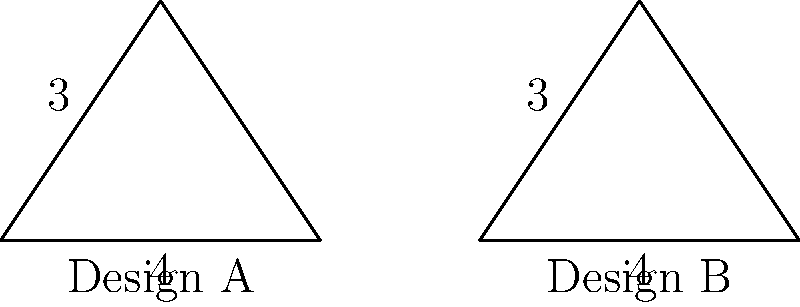Two self-driving taxi designs, A and B, have triangular safety sensor configurations as shown above. Which of the following statements about the congruence of these designs is correct?

a) The triangles are congruent because they have the same base and height.
b) The triangles are not congruent because their orientations are different.
c) The triangles are congruent because they have three pairs of congruent sides.
d) There is not enough information to determine if the triangles are congruent. To determine if the triangles are congruent, we need to analyze the given information:

1. Both triangles have a base of 4 units and a height of 3 units.
2. The triangles appear to be isosceles, with the base as the unequal side.

To prove congruence, we need to establish one of the following:
- SSS (Side-Side-Side)
- SAS (Side-Angle-Side)
- ASA (Angle-Side-Angle)
- AAS (Angle-Angle-Side)

Let's check if we have enough information:

1. We know the base (4 units) and height (3 units) of both triangles.
2. Using the Pythagorean theorem, we can calculate the length of the equal sides:
   $\text{side}^2 = (\frac{4}{2})^2 + 3^2 = 2^2 + 3^2 = 4 + 9 = 13$
   $\text{side} = \sqrt{13}$

3. Now we have all three sides of both triangles:
   - Base: 4 units
   - Two equal sides: $\sqrt{13}$ units each

4. Since all three pairs of corresponding sides are equal, we can conclude that the triangles are congruent by the SSS (Side-Side-Side) congruence criterion.

Therefore, the correct answer is c) The triangles are congruent because they have three pairs of congruent sides.
Answer: c) The triangles are congruent because they have three pairs of congruent sides. 